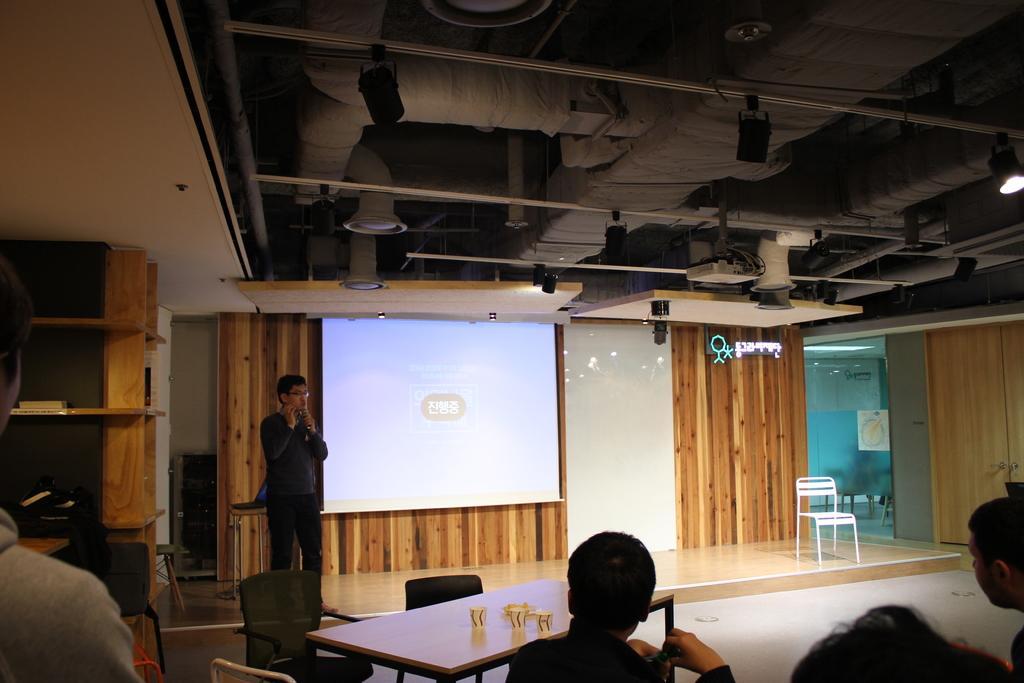Can you describe this image briefly? Here in this picture, in the middle we can see a person standing on the floor and speaking something and behind him on the wall we can see a projector screen with something projected on it and in front of him we can see number of tables and chairs present and some people are sitting on it and listening him and on the right side we can see a chair present and at the top we can see lights present and we can also see a projector present and on the left side we can see some things present in the racks. 